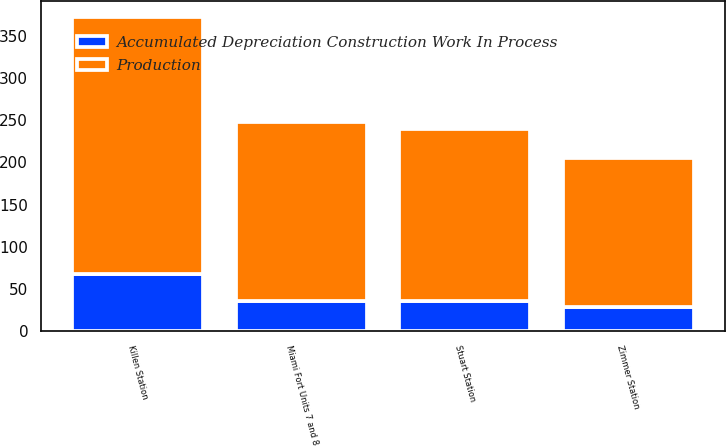Convert chart to OTSL. <chart><loc_0><loc_0><loc_500><loc_500><stacked_bar_chart><ecel><fcel>Killen Station<fcel>Miami Fort Units 7 and 8<fcel>Stuart Station<fcel>Zimmer Station<nl><fcel>Accumulated Depreciation Construction Work In Process<fcel>67<fcel>36<fcel>35<fcel>28<nl><fcel>Production<fcel>306<fcel>212<fcel>205<fcel>177<nl></chart> 